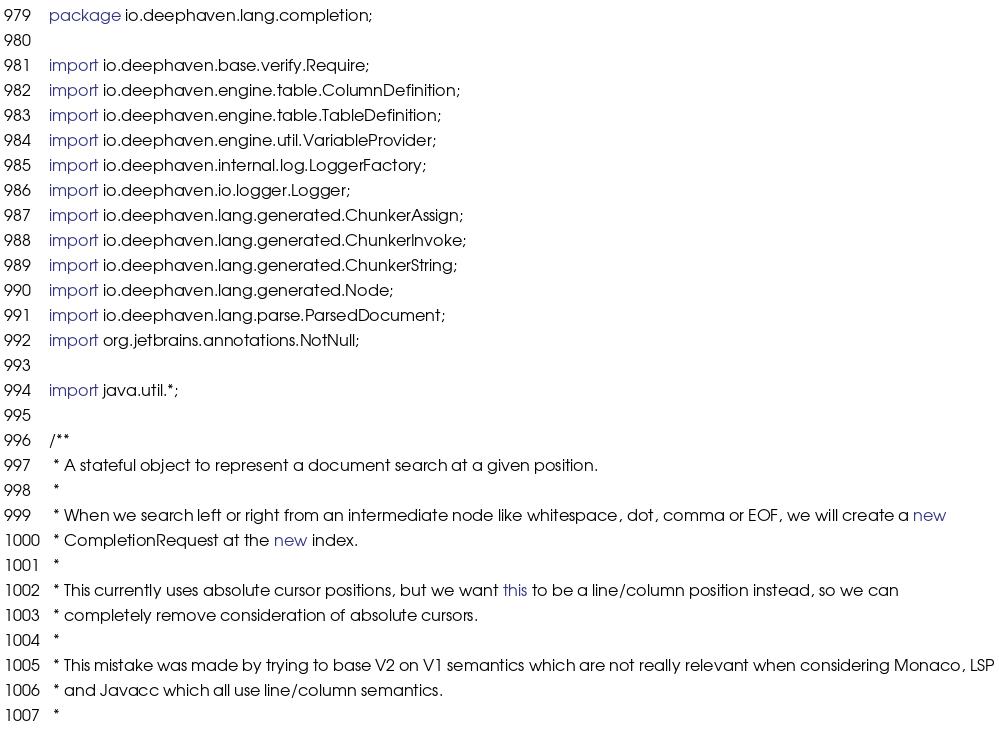<code> <loc_0><loc_0><loc_500><loc_500><_Java_>package io.deephaven.lang.completion;

import io.deephaven.base.verify.Require;
import io.deephaven.engine.table.ColumnDefinition;
import io.deephaven.engine.table.TableDefinition;
import io.deephaven.engine.util.VariableProvider;
import io.deephaven.internal.log.LoggerFactory;
import io.deephaven.io.logger.Logger;
import io.deephaven.lang.generated.ChunkerAssign;
import io.deephaven.lang.generated.ChunkerInvoke;
import io.deephaven.lang.generated.ChunkerString;
import io.deephaven.lang.generated.Node;
import io.deephaven.lang.parse.ParsedDocument;
import org.jetbrains.annotations.NotNull;

import java.util.*;

/**
 * A stateful object to represent a document search at a given position.
 *
 * When we search left or right from an intermediate node like whitespace, dot, comma or EOF, we will create a new
 * CompletionRequest at the new index.
 *
 * This currently uses absolute cursor positions, but we want this to be a line/column position instead, so we can
 * completely remove consideration of absolute cursors.
 *
 * This mistake was made by trying to base V2 on V1 semantics which are not really relevant when considering Monaco, LSP
 * and Javacc which all use line/column semantics.
 *</code> 